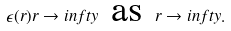Convert formula to latex. <formula><loc_0><loc_0><loc_500><loc_500>\epsilon ( r ) r \to i n f t y \text { as } r \to i n f t y .</formula> 